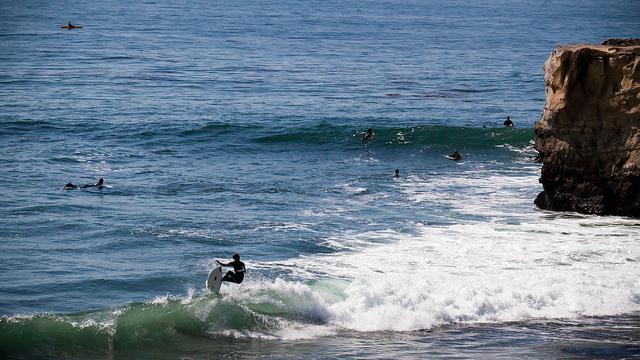Where was this picture taken?
Answer briefly. Beach. How many humans are in the ocean?
Keep it brief. 7. What activity are they taking part in?
Short answer required. Surfing. 